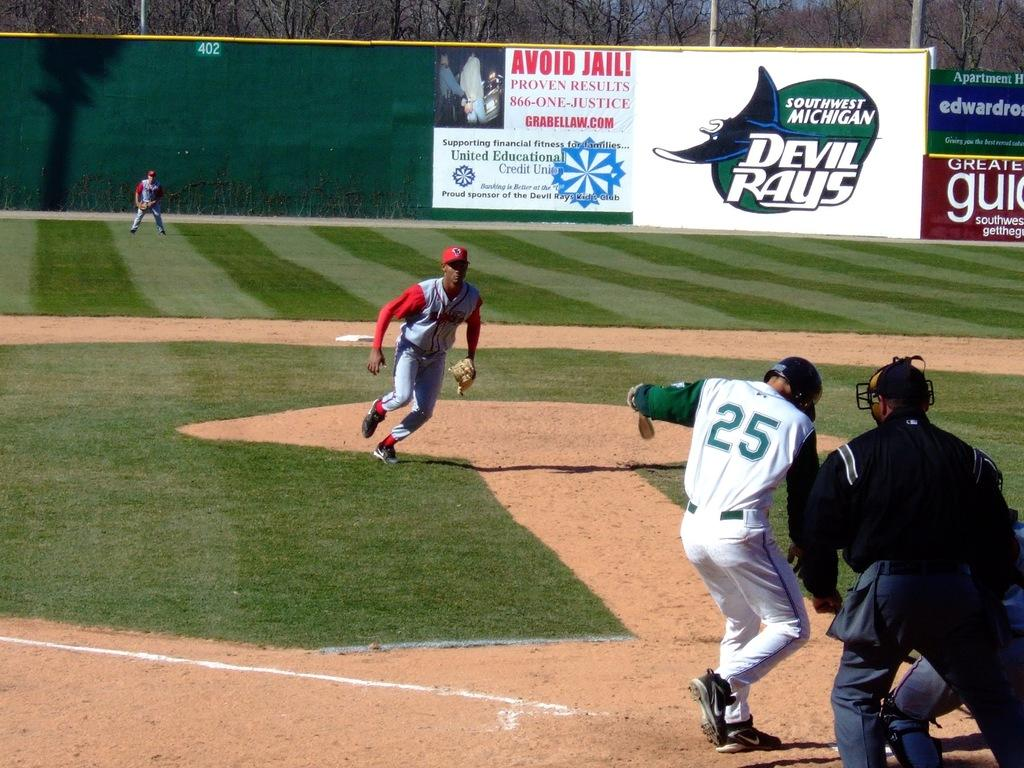Provide a one-sentence caption for the provided image. A baseball player with 25 on his jersey kicking at dust. 